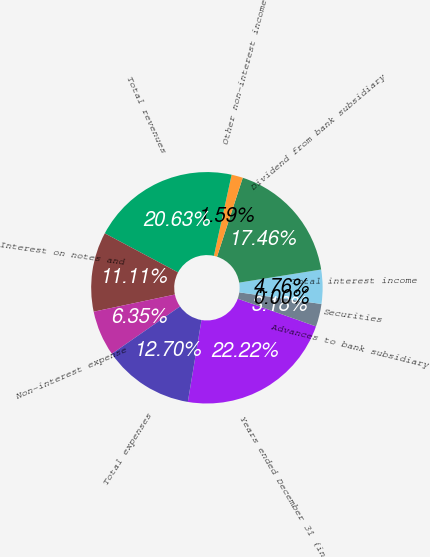<chart> <loc_0><loc_0><loc_500><loc_500><pie_chart><fcel>Years ended December 31 (in<fcel>Advances to bank subsidiary<fcel>Securities<fcel>Total interest income<fcel>Dividend from bank subsidiary<fcel>Other non-interest income<fcel>Total revenues<fcel>Interest on notes and<fcel>Non-interest expense<fcel>Total expenses<nl><fcel>22.22%<fcel>3.18%<fcel>0.0%<fcel>4.76%<fcel>17.46%<fcel>1.59%<fcel>20.63%<fcel>11.11%<fcel>6.35%<fcel>12.7%<nl></chart> 